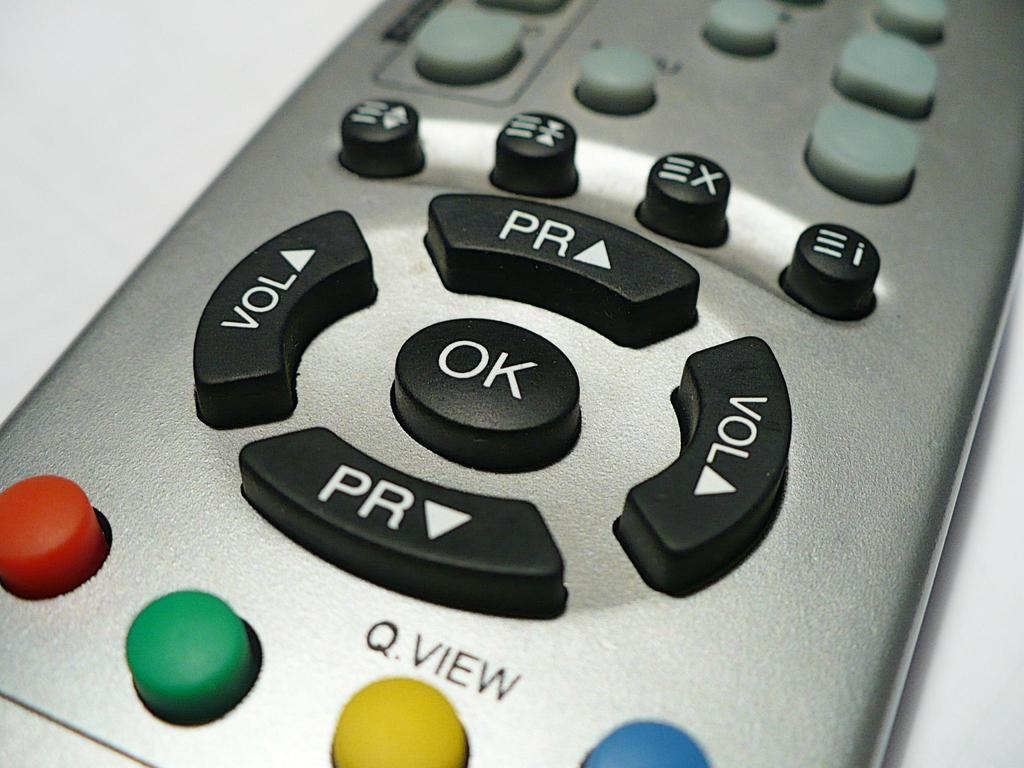<image>
Write a terse but informative summary of the picture. A silver remote control with colored and black buttons one of which says OK. 